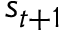Convert formula to latex. <formula><loc_0><loc_0><loc_500><loc_500>s _ { t + 1 }</formula> 